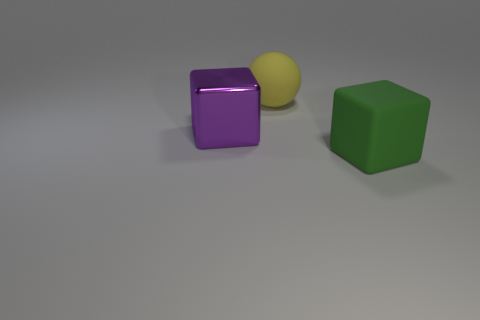There is a purple object; how many large objects are in front of it?
Give a very brief answer. 1. What number of big green blocks have the same material as the big yellow thing?
Provide a short and direct response. 1. There is a object that is the same material as the yellow ball; what is its color?
Your answer should be compact. Green. What material is the cube to the left of the matte object that is behind the cube to the right of the yellow rubber sphere?
Give a very brief answer. Metal. How many tiny things are purple objects or yellow metallic balls?
Your answer should be very brief. 0. Is there a big rubber sphere that has the same color as the big rubber cube?
Ensure brevity in your answer.  No. The green object that is the same size as the matte sphere is what shape?
Provide a short and direct response. Cube. How many things are either large objects that are behind the big green matte block or spheres?
Offer a very short reply. 2. Is the number of rubber things behind the green thing greater than the number of large purple blocks that are on the right side of the yellow object?
Offer a very short reply. Yes. Does the yellow ball have the same material as the green cube?
Provide a succinct answer. Yes. 